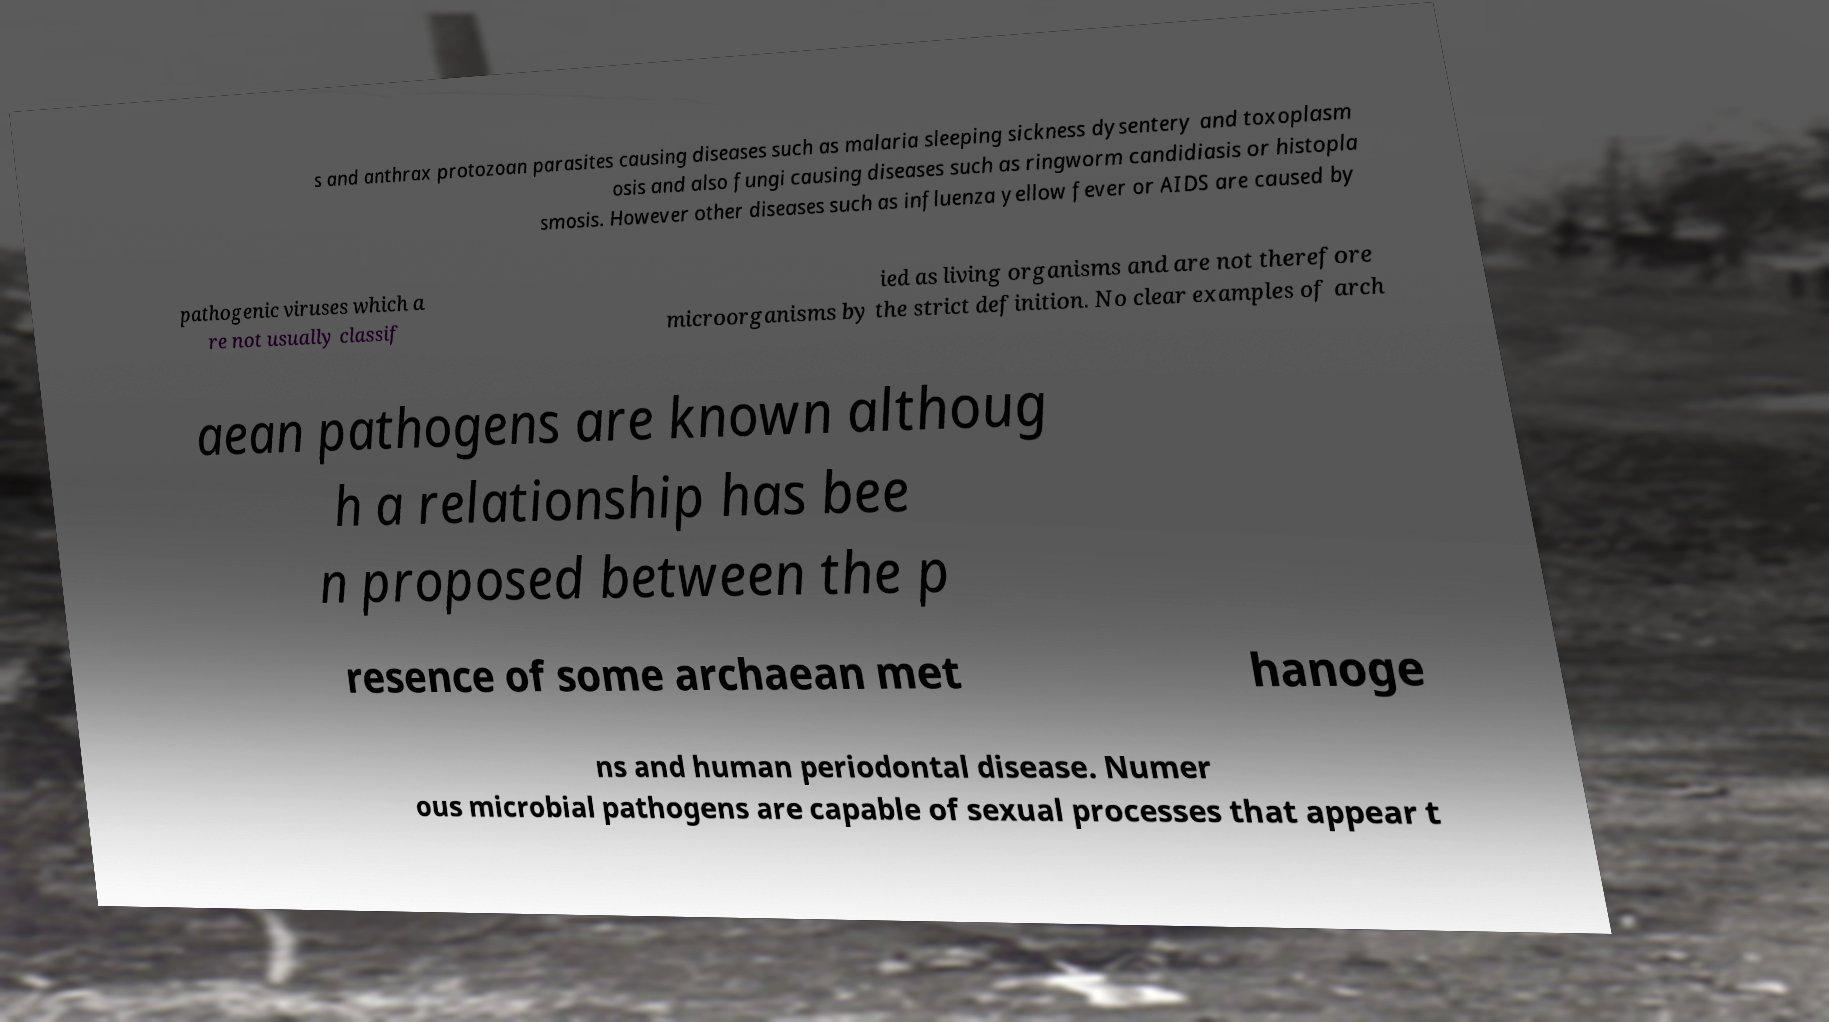Could you extract and type out the text from this image? s and anthrax protozoan parasites causing diseases such as malaria sleeping sickness dysentery and toxoplasm osis and also fungi causing diseases such as ringworm candidiasis or histopla smosis. However other diseases such as influenza yellow fever or AIDS are caused by pathogenic viruses which a re not usually classif ied as living organisms and are not therefore microorganisms by the strict definition. No clear examples of arch aean pathogens are known althoug h a relationship has bee n proposed between the p resence of some archaean met hanoge ns and human periodontal disease. Numer ous microbial pathogens are capable of sexual processes that appear t 